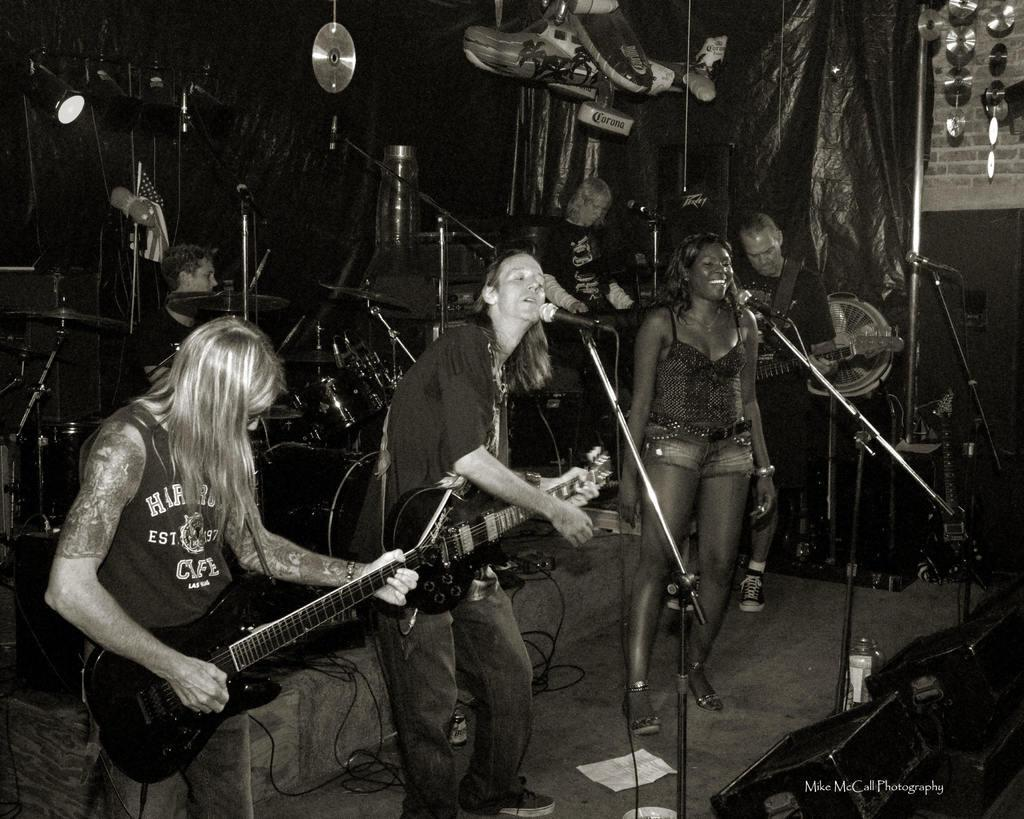What is happening in the image? There are people in the image, and they are holding and playing musical instruments. What objects are present to amplify the sound of their instruments? There are microphones in front of the people. What type of carriage can be seen in the image? There is no carriage present in the image. What kind of voyage are the people embarking on with their musical instruments? The image does not depict a voyage or any indication of travel. 